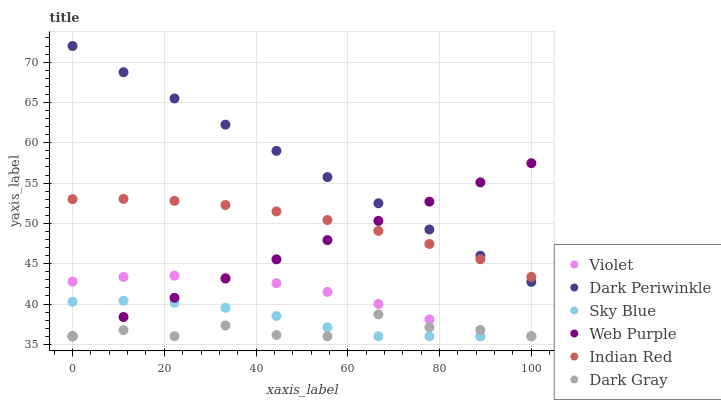Does Dark Gray have the minimum area under the curve?
Answer yes or no. Yes. Does Dark Periwinkle have the maximum area under the curve?
Answer yes or no. Yes. Does Web Purple have the minimum area under the curve?
Answer yes or no. No. Does Web Purple have the maximum area under the curve?
Answer yes or no. No. Is Dark Periwinkle the smoothest?
Answer yes or no. Yes. Is Dark Gray the roughest?
Answer yes or no. Yes. Is Web Purple the smoothest?
Answer yes or no. No. Is Web Purple the roughest?
Answer yes or no. No. Does Dark Gray have the lowest value?
Answer yes or no. Yes. Does Indian Red have the lowest value?
Answer yes or no. No. Does Dark Periwinkle have the highest value?
Answer yes or no. Yes. Does Web Purple have the highest value?
Answer yes or no. No. Is Sky Blue less than Dark Periwinkle?
Answer yes or no. Yes. Is Dark Periwinkle greater than Violet?
Answer yes or no. Yes. Does Indian Red intersect Dark Periwinkle?
Answer yes or no. Yes. Is Indian Red less than Dark Periwinkle?
Answer yes or no. No. Is Indian Red greater than Dark Periwinkle?
Answer yes or no. No. Does Sky Blue intersect Dark Periwinkle?
Answer yes or no. No. 